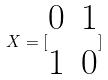<formula> <loc_0><loc_0><loc_500><loc_500>X = [ \begin{matrix} 0 & 1 \\ 1 & 0 \end{matrix} ]</formula> 